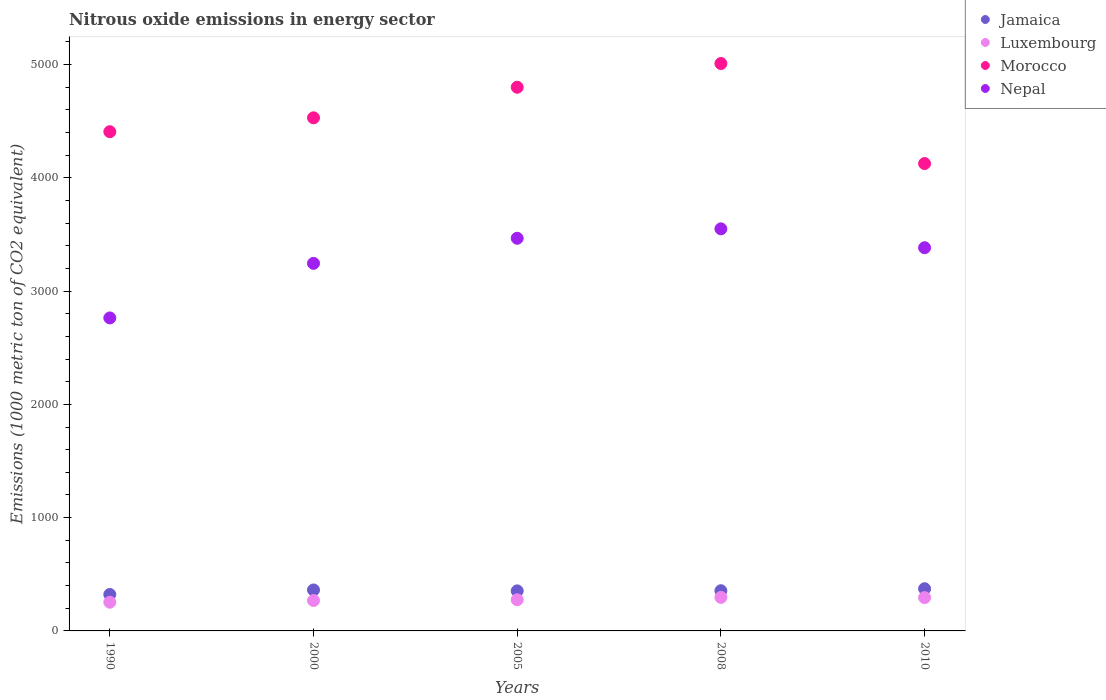Is the number of dotlines equal to the number of legend labels?
Make the answer very short. Yes. What is the amount of nitrous oxide emitted in Luxembourg in 2010?
Your answer should be very brief. 294.2. Across all years, what is the maximum amount of nitrous oxide emitted in Morocco?
Offer a terse response. 5008.9. Across all years, what is the minimum amount of nitrous oxide emitted in Morocco?
Provide a succinct answer. 4125.7. In which year was the amount of nitrous oxide emitted in Jamaica maximum?
Keep it short and to the point. 2010. What is the total amount of nitrous oxide emitted in Jamaica in the graph?
Your response must be concise. 1764.1. What is the difference between the amount of nitrous oxide emitted in Morocco in 2000 and that in 2010?
Offer a very short reply. 403.8. What is the difference between the amount of nitrous oxide emitted in Jamaica in 2005 and the amount of nitrous oxide emitted in Luxembourg in 1990?
Your response must be concise. 99.9. What is the average amount of nitrous oxide emitted in Morocco per year?
Keep it short and to the point. 4574.08. In the year 2008, what is the difference between the amount of nitrous oxide emitted in Luxembourg and amount of nitrous oxide emitted in Jamaica?
Ensure brevity in your answer.  -58.6. In how many years, is the amount of nitrous oxide emitted in Jamaica greater than 2400 1000 metric ton?
Make the answer very short. 0. What is the ratio of the amount of nitrous oxide emitted in Morocco in 1990 to that in 2005?
Ensure brevity in your answer.  0.92. Is the difference between the amount of nitrous oxide emitted in Luxembourg in 2005 and 2008 greater than the difference between the amount of nitrous oxide emitted in Jamaica in 2005 and 2008?
Give a very brief answer. No. What is the difference between the highest and the second highest amount of nitrous oxide emitted in Nepal?
Offer a very short reply. 83.2. What is the difference between the highest and the lowest amount of nitrous oxide emitted in Luxembourg?
Give a very brief answer. 42.6. In how many years, is the amount of nitrous oxide emitted in Jamaica greater than the average amount of nitrous oxide emitted in Jamaica taken over all years?
Give a very brief answer. 4. Is the sum of the amount of nitrous oxide emitted in Luxembourg in 2008 and 2010 greater than the maximum amount of nitrous oxide emitted in Jamaica across all years?
Give a very brief answer. Yes. Is it the case that in every year, the sum of the amount of nitrous oxide emitted in Luxembourg and amount of nitrous oxide emitted in Morocco  is greater than the amount of nitrous oxide emitted in Nepal?
Give a very brief answer. Yes. Does the amount of nitrous oxide emitted in Morocco monotonically increase over the years?
Give a very brief answer. No. Is the amount of nitrous oxide emitted in Nepal strictly greater than the amount of nitrous oxide emitted in Jamaica over the years?
Provide a short and direct response. Yes. Is the amount of nitrous oxide emitted in Jamaica strictly less than the amount of nitrous oxide emitted in Morocco over the years?
Your answer should be very brief. Yes. How many years are there in the graph?
Your answer should be very brief. 5. What is the difference between two consecutive major ticks on the Y-axis?
Offer a terse response. 1000. Does the graph contain grids?
Keep it short and to the point. No. Where does the legend appear in the graph?
Your answer should be compact. Top right. How are the legend labels stacked?
Offer a very short reply. Vertical. What is the title of the graph?
Offer a terse response. Nitrous oxide emissions in energy sector. What is the label or title of the Y-axis?
Your response must be concise. Emissions (1000 metric ton of CO2 equivalent). What is the Emissions (1000 metric ton of CO2 equivalent) in Jamaica in 1990?
Provide a succinct answer. 321.7. What is the Emissions (1000 metric ton of CO2 equivalent) of Luxembourg in 1990?
Provide a short and direct response. 253.6. What is the Emissions (1000 metric ton of CO2 equivalent) of Morocco in 1990?
Your response must be concise. 4406.9. What is the Emissions (1000 metric ton of CO2 equivalent) of Nepal in 1990?
Your response must be concise. 2763. What is the Emissions (1000 metric ton of CO2 equivalent) of Jamaica in 2000?
Ensure brevity in your answer.  361.6. What is the Emissions (1000 metric ton of CO2 equivalent) in Luxembourg in 2000?
Give a very brief answer. 268.4. What is the Emissions (1000 metric ton of CO2 equivalent) in Morocco in 2000?
Your answer should be very brief. 4529.5. What is the Emissions (1000 metric ton of CO2 equivalent) of Nepal in 2000?
Your answer should be compact. 3244.8. What is the Emissions (1000 metric ton of CO2 equivalent) in Jamaica in 2005?
Make the answer very short. 353.5. What is the Emissions (1000 metric ton of CO2 equivalent) in Luxembourg in 2005?
Your response must be concise. 275.3. What is the Emissions (1000 metric ton of CO2 equivalent) of Morocco in 2005?
Make the answer very short. 4799.4. What is the Emissions (1000 metric ton of CO2 equivalent) in Nepal in 2005?
Your answer should be very brief. 3466.2. What is the Emissions (1000 metric ton of CO2 equivalent) of Jamaica in 2008?
Provide a succinct answer. 354.8. What is the Emissions (1000 metric ton of CO2 equivalent) in Luxembourg in 2008?
Give a very brief answer. 296.2. What is the Emissions (1000 metric ton of CO2 equivalent) in Morocco in 2008?
Your response must be concise. 5008.9. What is the Emissions (1000 metric ton of CO2 equivalent) of Nepal in 2008?
Offer a terse response. 3549.4. What is the Emissions (1000 metric ton of CO2 equivalent) of Jamaica in 2010?
Ensure brevity in your answer.  372.5. What is the Emissions (1000 metric ton of CO2 equivalent) of Luxembourg in 2010?
Your answer should be very brief. 294.2. What is the Emissions (1000 metric ton of CO2 equivalent) in Morocco in 2010?
Give a very brief answer. 4125.7. What is the Emissions (1000 metric ton of CO2 equivalent) of Nepal in 2010?
Provide a succinct answer. 3382.9. Across all years, what is the maximum Emissions (1000 metric ton of CO2 equivalent) in Jamaica?
Make the answer very short. 372.5. Across all years, what is the maximum Emissions (1000 metric ton of CO2 equivalent) in Luxembourg?
Ensure brevity in your answer.  296.2. Across all years, what is the maximum Emissions (1000 metric ton of CO2 equivalent) in Morocco?
Keep it short and to the point. 5008.9. Across all years, what is the maximum Emissions (1000 metric ton of CO2 equivalent) of Nepal?
Your answer should be compact. 3549.4. Across all years, what is the minimum Emissions (1000 metric ton of CO2 equivalent) of Jamaica?
Offer a very short reply. 321.7. Across all years, what is the minimum Emissions (1000 metric ton of CO2 equivalent) in Luxembourg?
Your answer should be very brief. 253.6. Across all years, what is the minimum Emissions (1000 metric ton of CO2 equivalent) in Morocco?
Provide a short and direct response. 4125.7. Across all years, what is the minimum Emissions (1000 metric ton of CO2 equivalent) in Nepal?
Your answer should be very brief. 2763. What is the total Emissions (1000 metric ton of CO2 equivalent) of Jamaica in the graph?
Keep it short and to the point. 1764.1. What is the total Emissions (1000 metric ton of CO2 equivalent) of Luxembourg in the graph?
Offer a terse response. 1387.7. What is the total Emissions (1000 metric ton of CO2 equivalent) in Morocco in the graph?
Ensure brevity in your answer.  2.29e+04. What is the total Emissions (1000 metric ton of CO2 equivalent) of Nepal in the graph?
Your answer should be compact. 1.64e+04. What is the difference between the Emissions (1000 metric ton of CO2 equivalent) of Jamaica in 1990 and that in 2000?
Your response must be concise. -39.9. What is the difference between the Emissions (1000 metric ton of CO2 equivalent) in Luxembourg in 1990 and that in 2000?
Give a very brief answer. -14.8. What is the difference between the Emissions (1000 metric ton of CO2 equivalent) in Morocco in 1990 and that in 2000?
Your answer should be compact. -122.6. What is the difference between the Emissions (1000 metric ton of CO2 equivalent) in Nepal in 1990 and that in 2000?
Make the answer very short. -481.8. What is the difference between the Emissions (1000 metric ton of CO2 equivalent) of Jamaica in 1990 and that in 2005?
Ensure brevity in your answer.  -31.8. What is the difference between the Emissions (1000 metric ton of CO2 equivalent) of Luxembourg in 1990 and that in 2005?
Your response must be concise. -21.7. What is the difference between the Emissions (1000 metric ton of CO2 equivalent) in Morocco in 1990 and that in 2005?
Provide a short and direct response. -392.5. What is the difference between the Emissions (1000 metric ton of CO2 equivalent) in Nepal in 1990 and that in 2005?
Give a very brief answer. -703.2. What is the difference between the Emissions (1000 metric ton of CO2 equivalent) in Jamaica in 1990 and that in 2008?
Provide a short and direct response. -33.1. What is the difference between the Emissions (1000 metric ton of CO2 equivalent) in Luxembourg in 1990 and that in 2008?
Give a very brief answer. -42.6. What is the difference between the Emissions (1000 metric ton of CO2 equivalent) of Morocco in 1990 and that in 2008?
Keep it short and to the point. -602. What is the difference between the Emissions (1000 metric ton of CO2 equivalent) of Nepal in 1990 and that in 2008?
Keep it short and to the point. -786.4. What is the difference between the Emissions (1000 metric ton of CO2 equivalent) of Jamaica in 1990 and that in 2010?
Provide a succinct answer. -50.8. What is the difference between the Emissions (1000 metric ton of CO2 equivalent) of Luxembourg in 1990 and that in 2010?
Your answer should be compact. -40.6. What is the difference between the Emissions (1000 metric ton of CO2 equivalent) of Morocco in 1990 and that in 2010?
Your response must be concise. 281.2. What is the difference between the Emissions (1000 metric ton of CO2 equivalent) in Nepal in 1990 and that in 2010?
Ensure brevity in your answer.  -619.9. What is the difference between the Emissions (1000 metric ton of CO2 equivalent) of Jamaica in 2000 and that in 2005?
Offer a terse response. 8.1. What is the difference between the Emissions (1000 metric ton of CO2 equivalent) of Morocco in 2000 and that in 2005?
Offer a terse response. -269.9. What is the difference between the Emissions (1000 metric ton of CO2 equivalent) of Nepal in 2000 and that in 2005?
Provide a succinct answer. -221.4. What is the difference between the Emissions (1000 metric ton of CO2 equivalent) in Jamaica in 2000 and that in 2008?
Provide a succinct answer. 6.8. What is the difference between the Emissions (1000 metric ton of CO2 equivalent) of Luxembourg in 2000 and that in 2008?
Keep it short and to the point. -27.8. What is the difference between the Emissions (1000 metric ton of CO2 equivalent) in Morocco in 2000 and that in 2008?
Your answer should be very brief. -479.4. What is the difference between the Emissions (1000 metric ton of CO2 equivalent) of Nepal in 2000 and that in 2008?
Keep it short and to the point. -304.6. What is the difference between the Emissions (1000 metric ton of CO2 equivalent) in Luxembourg in 2000 and that in 2010?
Your response must be concise. -25.8. What is the difference between the Emissions (1000 metric ton of CO2 equivalent) of Morocco in 2000 and that in 2010?
Give a very brief answer. 403.8. What is the difference between the Emissions (1000 metric ton of CO2 equivalent) in Nepal in 2000 and that in 2010?
Your answer should be very brief. -138.1. What is the difference between the Emissions (1000 metric ton of CO2 equivalent) in Jamaica in 2005 and that in 2008?
Provide a short and direct response. -1.3. What is the difference between the Emissions (1000 metric ton of CO2 equivalent) of Luxembourg in 2005 and that in 2008?
Ensure brevity in your answer.  -20.9. What is the difference between the Emissions (1000 metric ton of CO2 equivalent) of Morocco in 2005 and that in 2008?
Provide a succinct answer. -209.5. What is the difference between the Emissions (1000 metric ton of CO2 equivalent) of Nepal in 2005 and that in 2008?
Offer a very short reply. -83.2. What is the difference between the Emissions (1000 metric ton of CO2 equivalent) of Luxembourg in 2005 and that in 2010?
Give a very brief answer. -18.9. What is the difference between the Emissions (1000 metric ton of CO2 equivalent) in Morocco in 2005 and that in 2010?
Keep it short and to the point. 673.7. What is the difference between the Emissions (1000 metric ton of CO2 equivalent) in Nepal in 2005 and that in 2010?
Your response must be concise. 83.3. What is the difference between the Emissions (1000 metric ton of CO2 equivalent) of Jamaica in 2008 and that in 2010?
Your answer should be compact. -17.7. What is the difference between the Emissions (1000 metric ton of CO2 equivalent) in Morocco in 2008 and that in 2010?
Ensure brevity in your answer.  883.2. What is the difference between the Emissions (1000 metric ton of CO2 equivalent) of Nepal in 2008 and that in 2010?
Your answer should be very brief. 166.5. What is the difference between the Emissions (1000 metric ton of CO2 equivalent) in Jamaica in 1990 and the Emissions (1000 metric ton of CO2 equivalent) in Luxembourg in 2000?
Your answer should be very brief. 53.3. What is the difference between the Emissions (1000 metric ton of CO2 equivalent) in Jamaica in 1990 and the Emissions (1000 metric ton of CO2 equivalent) in Morocco in 2000?
Provide a short and direct response. -4207.8. What is the difference between the Emissions (1000 metric ton of CO2 equivalent) in Jamaica in 1990 and the Emissions (1000 metric ton of CO2 equivalent) in Nepal in 2000?
Your answer should be compact. -2923.1. What is the difference between the Emissions (1000 metric ton of CO2 equivalent) in Luxembourg in 1990 and the Emissions (1000 metric ton of CO2 equivalent) in Morocco in 2000?
Provide a succinct answer. -4275.9. What is the difference between the Emissions (1000 metric ton of CO2 equivalent) in Luxembourg in 1990 and the Emissions (1000 metric ton of CO2 equivalent) in Nepal in 2000?
Provide a short and direct response. -2991.2. What is the difference between the Emissions (1000 metric ton of CO2 equivalent) of Morocco in 1990 and the Emissions (1000 metric ton of CO2 equivalent) of Nepal in 2000?
Make the answer very short. 1162.1. What is the difference between the Emissions (1000 metric ton of CO2 equivalent) in Jamaica in 1990 and the Emissions (1000 metric ton of CO2 equivalent) in Luxembourg in 2005?
Offer a very short reply. 46.4. What is the difference between the Emissions (1000 metric ton of CO2 equivalent) of Jamaica in 1990 and the Emissions (1000 metric ton of CO2 equivalent) of Morocco in 2005?
Ensure brevity in your answer.  -4477.7. What is the difference between the Emissions (1000 metric ton of CO2 equivalent) of Jamaica in 1990 and the Emissions (1000 metric ton of CO2 equivalent) of Nepal in 2005?
Make the answer very short. -3144.5. What is the difference between the Emissions (1000 metric ton of CO2 equivalent) of Luxembourg in 1990 and the Emissions (1000 metric ton of CO2 equivalent) of Morocco in 2005?
Offer a very short reply. -4545.8. What is the difference between the Emissions (1000 metric ton of CO2 equivalent) in Luxembourg in 1990 and the Emissions (1000 metric ton of CO2 equivalent) in Nepal in 2005?
Offer a very short reply. -3212.6. What is the difference between the Emissions (1000 metric ton of CO2 equivalent) of Morocco in 1990 and the Emissions (1000 metric ton of CO2 equivalent) of Nepal in 2005?
Ensure brevity in your answer.  940.7. What is the difference between the Emissions (1000 metric ton of CO2 equivalent) in Jamaica in 1990 and the Emissions (1000 metric ton of CO2 equivalent) in Morocco in 2008?
Your answer should be very brief. -4687.2. What is the difference between the Emissions (1000 metric ton of CO2 equivalent) of Jamaica in 1990 and the Emissions (1000 metric ton of CO2 equivalent) of Nepal in 2008?
Offer a terse response. -3227.7. What is the difference between the Emissions (1000 metric ton of CO2 equivalent) of Luxembourg in 1990 and the Emissions (1000 metric ton of CO2 equivalent) of Morocco in 2008?
Offer a very short reply. -4755.3. What is the difference between the Emissions (1000 metric ton of CO2 equivalent) of Luxembourg in 1990 and the Emissions (1000 metric ton of CO2 equivalent) of Nepal in 2008?
Provide a succinct answer. -3295.8. What is the difference between the Emissions (1000 metric ton of CO2 equivalent) of Morocco in 1990 and the Emissions (1000 metric ton of CO2 equivalent) of Nepal in 2008?
Keep it short and to the point. 857.5. What is the difference between the Emissions (1000 metric ton of CO2 equivalent) of Jamaica in 1990 and the Emissions (1000 metric ton of CO2 equivalent) of Morocco in 2010?
Provide a succinct answer. -3804. What is the difference between the Emissions (1000 metric ton of CO2 equivalent) in Jamaica in 1990 and the Emissions (1000 metric ton of CO2 equivalent) in Nepal in 2010?
Provide a succinct answer. -3061.2. What is the difference between the Emissions (1000 metric ton of CO2 equivalent) of Luxembourg in 1990 and the Emissions (1000 metric ton of CO2 equivalent) of Morocco in 2010?
Ensure brevity in your answer.  -3872.1. What is the difference between the Emissions (1000 metric ton of CO2 equivalent) of Luxembourg in 1990 and the Emissions (1000 metric ton of CO2 equivalent) of Nepal in 2010?
Give a very brief answer. -3129.3. What is the difference between the Emissions (1000 metric ton of CO2 equivalent) in Morocco in 1990 and the Emissions (1000 metric ton of CO2 equivalent) in Nepal in 2010?
Provide a succinct answer. 1024. What is the difference between the Emissions (1000 metric ton of CO2 equivalent) of Jamaica in 2000 and the Emissions (1000 metric ton of CO2 equivalent) of Luxembourg in 2005?
Your answer should be compact. 86.3. What is the difference between the Emissions (1000 metric ton of CO2 equivalent) in Jamaica in 2000 and the Emissions (1000 metric ton of CO2 equivalent) in Morocco in 2005?
Ensure brevity in your answer.  -4437.8. What is the difference between the Emissions (1000 metric ton of CO2 equivalent) of Jamaica in 2000 and the Emissions (1000 metric ton of CO2 equivalent) of Nepal in 2005?
Your answer should be compact. -3104.6. What is the difference between the Emissions (1000 metric ton of CO2 equivalent) of Luxembourg in 2000 and the Emissions (1000 metric ton of CO2 equivalent) of Morocco in 2005?
Keep it short and to the point. -4531. What is the difference between the Emissions (1000 metric ton of CO2 equivalent) in Luxembourg in 2000 and the Emissions (1000 metric ton of CO2 equivalent) in Nepal in 2005?
Provide a succinct answer. -3197.8. What is the difference between the Emissions (1000 metric ton of CO2 equivalent) of Morocco in 2000 and the Emissions (1000 metric ton of CO2 equivalent) of Nepal in 2005?
Give a very brief answer. 1063.3. What is the difference between the Emissions (1000 metric ton of CO2 equivalent) of Jamaica in 2000 and the Emissions (1000 metric ton of CO2 equivalent) of Luxembourg in 2008?
Make the answer very short. 65.4. What is the difference between the Emissions (1000 metric ton of CO2 equivalent) of Jamaica in 2000 and the Emissions (1000 metric ton of CO2 equivalent) of Morocco in 2008?
Ensure brevity in your answer.  -4647.3. What is the difference between the Emissions (1000 metric ton of CO2 equivalent) of Jamaica in 2000 and the Emissions (1000 metric ton of CO2 equivalent) of Nepal in 2008?
Provide a succinct answer. -3187.8. What is the difference between the Emissions (1000 metric ton of CO2 equivalent) of Luxembourg in 2000 and the Emissions (1000 metric ton of CO2 equivalent) of Morocco in 2008?
Offer a very short reply. -4740.5. What is the difference between the Emissions (1000 metric ton of CO2 equivalent) in Luxembourg in 2000 and the Emissions (1000 metric ton of CO2 equivalent) in Nepal in 2008?
Keep it short and to the point. -3281. What is the difference between the Emissions (1000 metric ton of CO2 equivalent) of Morocco in 2000 and the Emissions (1000 metric ton of CO2 equivalent) of Nepal in 2008?
Offer a very short reply. 980.1. What is the difference between the Emissions (1000 metric ton of CO2 equivalent) of Jamaica in 2000 and the Emissions (1000 metric ton of CO2 equivalent) of Luxembourg in 2010?
Offer a very short reply. 67.4. What is the difference between the Emissions (1000 metric ton of CO2 equivalent) of Jamaica in 2000 and the Emissions (1000 metric ton of CO2 equivalent) of Morocco in 2010?
Give a very brief answer. -3764.1. What is the difference between the Emissions (1000 metric ton of CO2 equivalent) of Jamaica in 2000 and the Emissions (1000 metric ton of CO2 equivalent) of Nepal in 2010?
Make the answer very short. -3021.3. What is the difference between the Emissions (1000 metric ton of CO2 equivalent) of Luxembourg in 2000 and the Emissions (1000 metric ton of CO2 equivalent) of Morocco in 2010?
Offer a terse response. -3857.3. What is the difference between the Emissions (1000 metric ton of CO2 equivalent) in Luxembourg in 2000 and the Emissions (1000 metric ton of CO2 equivalent) in Nepal in 2010?
Make the answer very short. -3114.5. What is the difference between the Emissions (1000 metric ton of CO2 equivalent) of Morocco in 2000 and the Emissions (1000 metric ton of CO2 equivalent) of Nepal in 2010?
Your answer should be very brief. 1146.6. What is the difference between the Emissions (1000 metric ton of CO2 equivalent) of Jamaica in 2005 and the Emissions (1000 metric ton of CO2 equivalent) of Luxembourg in 2008?
Your response must be concise. 57.3. What is the difference between the Emissions (1000 metric ton of CO2 equivalent) of Jamaica in 2005 and the Emissions (1000 metric ton of CO2 equivalent) of Morocco in 2008?
Your answer should be compact. -4655.4. What is the difference between the Emissions (1000 metric ton of CO2 equivalent) of Jamaica in 2005 and the Emissions (1000 metric ton of CO2 equivalent) of Nepal in 2008?
Offer a terse response. -3195.9. What is the difference between the Emissions (1000 metric ton of CO2 equivalent) in Luxembourg in 2005 and the Emissions (1000 metric ton of CO2 equivalent) in Morocco in 2008?
Your response must be concise. -4733.6. What is the difference between the Emissions (1000 metric ton of CO2 equivalent) in Luxembourg in 2005 and the Emissions (1000 metric ton of CO2 equivalent) in Nepal in 2008?
Your answer should be very brief. -3274.1. What is the difference between the Emissions (1000 metric ton of CO2 equivalent) of Morocco in 2005 and the Emissions (1000 metric ton of CO2 equivalent) of Nepal in 2008?
Ensure brevity in your answer.  1250. What is the difference between the Emissions (1000 metric ton of CO2 equivalent) of Jamaica in 2005 and the Emissions (1000 metric ton of CO2 equivalent) of Luxembourg in 2010?
Ensure brevity in your answer.  59.3. What is the difference between the Emissions (1000 metric ton of CO2 equivalent) of Jamaica in 2005 and the Emissions (1000 metric ton of CO2 equivalent) of Morocco in 2010?
Ensure brevity in your answer.  -3772.2. What is the difference between the Emissions (1000 metric ton of CO2 equivalent) in Jamaica in 2005 and the Emissions (1000 metric ton of CO2 equivalent) in Nepal in 2010?
Give a very brief answer. -3029.4. What is the difference between the Emissions (1000 metric ton of CO2 equivalent) in Luxembourg in 2005 and the Emissions (1000 metric ton of CO2 equivalent) in Morocco in 2010?
Your answer should be very brief. -3850.4. What is the difference between the Emissions (1000 metric ton of CO2 equivalent) of Luxembourg in 2005 and the Emissions (1000 metric ton of CO2 equivalent) of Nepal in 2010?
Give a very brief answer. -3107.6. What is the difference between the Emissions (1000 metric ton of CO2 equivalent) of Morocco in 2005 and the Emissions (1000 metric ton of CO2 equivalent) of Nepal in 2010?
Your response must be concise. 1416.5. What is the difference between the Emissions (1000 metric ton of CO2 equivalent) of Jamaica in 2008 and the Emissions (1000 metric ton of CO2 equivalent) of Luxembourg in 2010?
Your answer should be very brief. 60.6. What is the difference between the Emissions (1000 metric ton of CO2 equivalent) of Jamaica in 2008 and the Emissions (1000 metric ton of CO2 equivalent) of Morocco in 2010?
Your answer should be very brief. -3770.9. What is the difference between the Emissions (1000 metric ton of CO2 equivalent) of Jamaica in 2008 and the Emissions (1000 metric ton of CO2 equivalent) of Nepal in 2010?
Keep it short and to the point. -3028.1. What is the difference between the Emissions (1000 metric ton of CO2 equivalent) in Luxembourg in 2008 and the Emissions (1000 metric ton of CO2 equivalent) in Morocco in 2010?
Ensure brevity in your answer.  -3829.5. What is the difference between the Emissions (1000 metric ton of CO2 equivalent) of Luxembourg in 2008 and the Emissions (1000 metric ton of CO2 equivalent) of Nepal in 2010?
Your response must be concise. -3086.7. What is the difference between the Emissions (1000 metric ton of CO2 equivalent) of Morocco in 2008 and the Emissions (1000 metric ton of CO2 equivalent) of Nepal in 2010?
Give a very brief answer. 1626. What is the average Emissions (1000 metric ton of CO2 equivalent) in Jamaica per year?
Offer a very short reply. 352.82. What is the average Emissions (1000 metric ton of CO2 equivalent) in Luxembourg per year?
Keep it short and to the point. 277.54. What is the average Emissions (1000 metric ton of CO2 equivalent) in Morocco per year?
Offer a terse response. 4574.08. What is the average Emissions (1000 metric ton of CO2 equivalent) of Nepal per year?
Your answer should be compact. 3281.26. In the year 1990, what is the difference between the Emissions (1000 metric ton of CO2 equivalent) of Jamaica and Emissions (1000 metric ton of CO2 equivalent) of Luxembourg?
Offer a very short reply. 68.1. In the year 1990, what is the difference between the Emissions (1000 metric ton of CO2 equivalent) in Jamaica and Emissions (1000 metric ton of CO2 equivalent) in Morocco?
Offer a terse response. -4085.2. In the year 1990, what is the difference between the Emissions (1000 metric ton of CO2 equivalent) of Jamaica and Emissions (1000 metric ton of CO2 equivalent) of Nepal?
Make the answer very short. -2441.3. In the year 1990, what is the difference between the Emissions (1000 metric ton of CO2 equivalent) in Luxembourg and Emissions (1000 metric ton of CO2 equivalent) in Morocco?
Offer a very short reply. -4153.3. In the year 1990, what is the difference between the Emissions (1000 metric ton of CO2 equivalent) in Luxembourg and Emissions (1000 metric ton of CO2 equivalent) in Nepal?
Keep it short and to the point. -2509.4. In the year 1990, what is the difference between the Emissions (1000 metric ton of CO2 equivalent) in Morocco and Emissions (1000 metric ton of CO2 equivalent) in Nepal?
Provide a succinct answer. 1643.9. In the year 2000, what is the difference between the Emissions (1000 metric ton of CO2 equivalent) of Jamaica and Emissions (1000 metric ton of CO2 equivalent) of Luxembourg?
Give a very brief answer. 93.2. In the year 2000, what is the difference between the Emissions (1000 metric ton of CO2 equivalent) of Jamaica and Emissions (1000 metric ton of CO2 equivalent) of Morocco?
Offer a very short reply. -4167.9. In the year 2000, what is the difference between the Emissions (1000 metric ton of CO2 equivalent) in Jamaica and Emissions (1000 metric ton of CO2 equivalent) in Nepal?
Offer a terse response. -2883.2. In the year 2000, what is the difference between the Emissions (1000 metric ton of CO2 equivalent) in Luxembourg and Emissions (1000 metric ton of CO2 equivalent) in Morocco?
Offer a very short reply. -4261.1. In the year 2000, what is the difference between the Emissions (1000 metric ton of CO2 equivalent) of Luxembourg and Emissions (1000 metric ton of CO2 equivalent) of Nepal?
Give a very brief answer. -2976.4. In the year 2000, what is the difference between the Emissions (1000 metric ton of CO2 equivalent) in Morocco and Emissions (1000 metric ton of CO2 equivalent) in Nepal?
Offer a very short reply. 1284.7. In the year 2005, what is the difference between the Emissions (1000 metric ton of CO2 equivalent) of Jamaica and Emissions (1000 metric ton of CO2 equivalent) of Luxembourg?
Offer a terse response. 78.2. In the year 2005, what is the difference between the Emissions (1000 metric ton of CO2 equivalent) in Jamaica and Emissions (1000 metric ton of CO2 equivalent) in Morocco?
Keep it short and to the point. -4445.9. In the year 2005, what is the difference between the Emissions (1000 metric ton of CO2 equivalent) in Jamaica and Emissions (1000 metric ton of CO2 equivalent) in Nepal?
Provide a succinct answer. -3112.7. In the year 2005, what is the difference between the Emissions (1000 metric ton of CO2 equivalent) in Luxembourg and Emissions (1000 metric ton of CO2 equivalent) in Morocco?
Offer a very short reply. -4524.1. In the year 2005, what is the difference between the Emissions (1000 metric ton of CO2 equivalent) in Luxembourg and Emissions (1000 metric ton of CO2 equivalent) in Nepal?
Your response must be concise. -3190.9. In the year 2005, what is the difference between the Emissions (1000 metric ton of CO2 equivalent) in Morocco and Emissions (1000 metric ton of CO2 equivalent) in Nepal?
Your response must be concise. 1333.2. In the year 2008, what is the difference between the Emissions (1000 metric ton of CO2 equivalent) of Jamaica and Emissions (1000 metric ton of CO2 equivalent) of Luxembourg?
Ensure brevity in your answer.  58.6. In the year 2008, what is the difference between the Emissions (1000 metric ton of CO2 equivalent) of Jamaica and Emissions (1000 metric ton of CO2 equivalent) of Morocco?
Keep it short and to the point. -4654.1. In the year 2008, what is the difference between the Emissions (1000 metric ton of CO2 equivalent) of Jamaica and Emissions (1000 metric ton of CO2 equivalent) of Nepal?
Provide a succinct answer. -3194.6. In the year 2008, what is the difference between the Emissions (1000 metric ton of CO2 equivalent) of Luxembourg and Emissions (1000 metric ton of CO2 equivalent) of Morocco?
Your response must be concise. -4712.7. In the year 2008, what is the difference between the Emissions (1000 metric ton of CO2 equivalent) of Luxembourg and Emissions (1000 metric ton of CO2 equivalent) of Nepal?
Offer a terse response. -3253.2. In the year 2008, what is the difference between the Emissions (1000 metric ton of CO2 equivalent) in Morocco and Emissions (1000 metric ton of CO2 equivalent) in Nepal?
Make the answer very short. 1459.5. In the year 2010, what is the difference between the Emissions (1000 metric ton of CO2 equivalent) of Jamaica and Emissions (1000 metric ton of CO2 equivalent) of Luxembourg?
Provide a succinct answer. 78.3. In the year 2010, what is the difference between the Emissions (1000 metric ton of CO2 equivalent) in Jamaica and Emissions (1000 metric ton of CO2 equivalent) in Morocco?
Your answer should be very brief. -3753.2. In the year 2010, what is the difference between the Emissions (1000 metric ton of CO2 equivalent) in Jamaica and Emissions (1000 metric ton of CO2 equivalent) in Nepal?
Your response must be concise. -3010.4. In the year 2010, what is the difference between the Emissions (1000 metric ton of CO2 equivalent) of Luxembourg and Emissions (1000 metric ton of CO2 equivalent) of Morocco?
Provide a succinct answer. -3831.5. In the year 2010, what is the difference between the Emissions (1000 metric ton of CO2 equivalent) of Luxembourg and Emissions (1000 metric ton of CO2 equivalent) of Nepal?
Your response must be concise. -3088.7. In the year 2010, what is the difference between the Emissions (1000 metric ton of CO2 equivalent) in Morocco and Emissions (1000 metric ton of CO2 equivalent) in Nepal?
Make the answer very short. 742.8. What is the ratio of the Emissions (1000 metric ton of CO2 equivalent) of Jamaica in 1990 to that in 2000?
Provide a short and direct response. 0.89. What is the ratio of the Emissions (1000 metric ton of CO2 equivalent) in Luxembourg in 1990 to that in 2000?
Your answer should be very brief. 0.94. What is the ratio of the Emissions (1000 metric ton of CO2 equivalent) in Morocco in 1990 to that in 2000?
Provide a succinct answer. 0.97. What is the ratio of the Emissions (1000 metric ton of CO2 equivalent) in Nepal in 1990 to that in 2000?
Provide a short and direct response. 0.85. What is the ratio of the Emissions (1000 metric ton of CO2 equivalent) in Jamaica in 1990 to that in 2005?
Provide a succinct answer. 0.91. What is the ratio of the Emissions (1000 metric ton of CO2 equivalent) in Luxembourg in 1990 to that in 2005?
Offer a terse response. 0.92. What is the ratio of the Emissions (1000 metric ton of CO2 equivalent) of Morocco in 1990 to that in 2005?
Make the answer very short. 0.92. What is the ratio of the Emissions (1000 metric ton of CO2 equivalent) in Nepal in 1990 to that in 2005?
Provide a short and direct response. 0.8. What is the ratio of the Emissions (1000 metric ton of CO2 equivalent) of Jamaica in 1990 to that in 2008?
Keep it short and to the point. 0.91. What is the ratio of the Emissions (1000 metric ton of CO2 equivalent) in Luxembourg in 1990 to that in 2008?
Offer a very short reply. 0.86. What is the ratio of the Emissions (1000 metric ton of CO2 equivalent) in Morocco in 1990 to that in 2008?
Give a very brief answer. 0.88. What is the ratio of the Emissions (1000 metric ton of CO2 equivalent) in Nepal in 1990 to that in 2008?
Ensure brevity in your answer.  0.78. What is the ratio of the Emissions (1000 metric ton of CO2 equivalent) in Jamaica in 1990 to that in 2010?
Your response must be concise. 0.86. What is the ratio of the Emissions (1000 metric ton of CO2 equivalent) of Luxembourg in 1990 to that in 2010?
Provide a short and direct response. 0.86. What is the ratio of the Emissions (1000 metric ton of CO2 equivalent) in Morocco in 1990 to that in 2010?
Ensure brevity in your answer.  1.07. What is the ratio of the Emissions (1000 metric ton of CO2 equivalent) of Nepal in 1990 to that in 2010?
Your answer should be very brief. 0.82. What is the ratio of the Emissions (1000 metric ton of CO2 equivalent) of Jamaica in 2000 to that in 2005?
Your answer should be very brief. 1.02. What is the ratio of the Emissions (1000 metric ton of CO2 equivalent) in Luxembourg in 2000 to that in 2005?
Your response must be concise. 0.97. What is the ratio of the Emissions (1000 metric ton of CO2 equivalent) of Morocco in 2000 to that in 2005?
Your answer should be compact. 0.94. What is the ratio of the Emissions (1000 metric ton of CO2 equivalent) in Nepal in 2000 to that in 2005?
Keep it short and to the point. 0.94. What is the ratio of the Emissions (1000 metric ton of CO2 equivalent) of Jamaica in 2000 to that in 2008?
Give a very brief answer. 1.02. What is the ratio of the Emissions (1000 metric ton of CO2 equivalent) of Luxembourg in 2000 to that in 2008?
Your response must be concise. 0.91. What is the ratio of the Emissions (1000 metric ton of CO2 equivalent) in Morocco in 2000 to that in 2008?
Keep it short and to the point. 0.9. What is the ratio of the Emissions (1000 metric ton of CO2 equivalent) in Nepal in 2000 to that in 2008?
Keep it short and to the point. 0.91. What is the ratio of the Emissions (1000 metric ton of CO2 equivalent) of Jamaica in 2000 to that in 2010?
Ensure brevity in your answer.  0.97. What is the ratio of the Emissions (1000 metric ton of CO2 equivalent) of Luxembourg in 2000 to that in 2010?
Ensure brevity in your answer.  0.91. What is the ratio of the Emissions (1000 metric ton of CO2 equivalent) in Morocco in 2000 to that in 2010?
Your answer should be compact. 1.1. What is the ratio of the Emissions (1000 metric ton of CO2 equivalent) in Nepal in 2000 to that in 2010?
Offer a very short reply. 0.96. What is the ratio of the Emissions (1000 metric ton of CO2 equivalent) in Jamaica in 2005 to that in 2008?
Keep it short and to the point. 1. What is the ratio of the Emissions (1000 metric ton of CO2 equivalent) of Luxembourg in 2005 to that in 2008?
Your answer should be very brief. 0.93. What is the ratio of the Emissions (1000 metric ton of CO2 equivalent) in Morocco in 2005 to that in 2008?
Offer a terse response. 0.96. What is the ratio of the Emissions (1000 metric ton of CO2 equivalent) of Nepal in 2005 to that in 2008?
Provide a short and direct response. 0.98. What is the ratio of the Emissions (1000 metric ton of CO2 equivalent) in Jamaica in 2005 to that in 2010?
Give a very brief answer. 0.95. What is the ratio of the Emissions (1000 metric ton of CO2 equivalent) in Luxembourg in 2005 to that in 2010?
Give a very brief answer. 0.94. What is the ratio of the Emissions (1000 metric ton of CO2 equivalent) in Morocco in 2005 to that in 2010?
Your answer should be compact. 1.16. What is the ratio of the Emissions (1000 metric ton of CO2 equivalent) of Nepal in 2005 to that in 2010?
Offer a very short reply. 1.02. What is the ratio of the Emissions (1000 metric ton of CO2 equivalent) in Jamaica in 2008 to that in 2010?
Your answer should be compact. 0.95. What is the ratio of the Emissions (1000 metric ton of CO2 equivalent) of Luxembourg in 2008 to that in 2010?
Offer a terse response. 1.01. What is the ratio of the Emissions (1000 metric ton of CO2 equivalent) of Morocco in 2008 to that in 2010?
Keep it short and to the point. 1.21. What is the ratio of the Emissions (1000 metric ton of CO2 equivalent) of Nepal in 2008 to that in 2010?
Make the answer very short. 1.05. What is the difference between the highest and the second highest Emissions (1000 metric ton of CO2 equivalent) of Morocco?
Your response must be concise. 209.5. What is the difference between the highest and the second highest Emissions (1000 metric ton of CO2 equivalent) of Nepal?
Offer a very short reply. 83.2. What is the difference between the highest and the lowest Emissions (1000 metric ton of CO2 equivalent) of Jamaica?
Keep it short and to the point. 50.8. What is the difference between the highest and the lowest Emissions (1000 metric ton of CO2 equivalent) in Luxembourg?
Your response must be concise. 42.6. What is the difference between the highest and the lowest Emissions (1000 metric ton of CO2 equivalent) of Morocco?
Ensure brevity in your answer.  883.2. What is the difference between the highest and the lowest Emissions (1000 metric ton of CO2 equivalent) in Nepal?
Your answer should be compact. 786.4. 